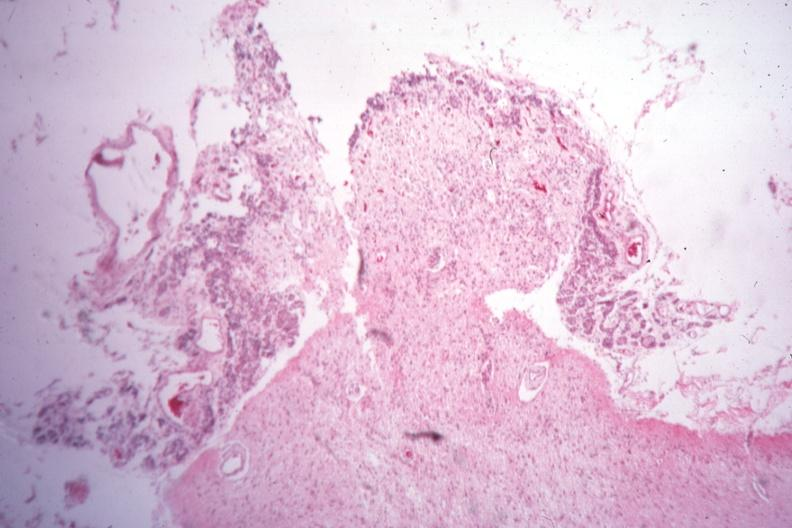what was sella of type i diabetes with pituitectomy for retinal lesions 9 years?
Answer the question using a single word or phrase. Empty case 